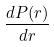Convert formula to latex. <formula><loc_0><loc_0><loc_500><loc_500>\frac { d P ( r ) } { d r }</formula> 